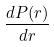Convert formula to latex. <formula><loc_0><loc_0><loc_500><loc_500>\frac { d P ( r ) } { d r }</formula> 